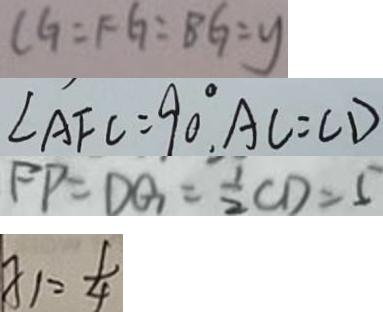Convert formula to latex. <formula><loc_0><loc_0><loc_500><loc_500>C G = F G = B G = y 
 \angle A F C = 9 0 ^ { \circ } , A C = C D 
 F P = D G = \frac { 1 } { 2 } C D = 5 
 x _ { 1 } = \frac { 1 } { 4 }</formula> 